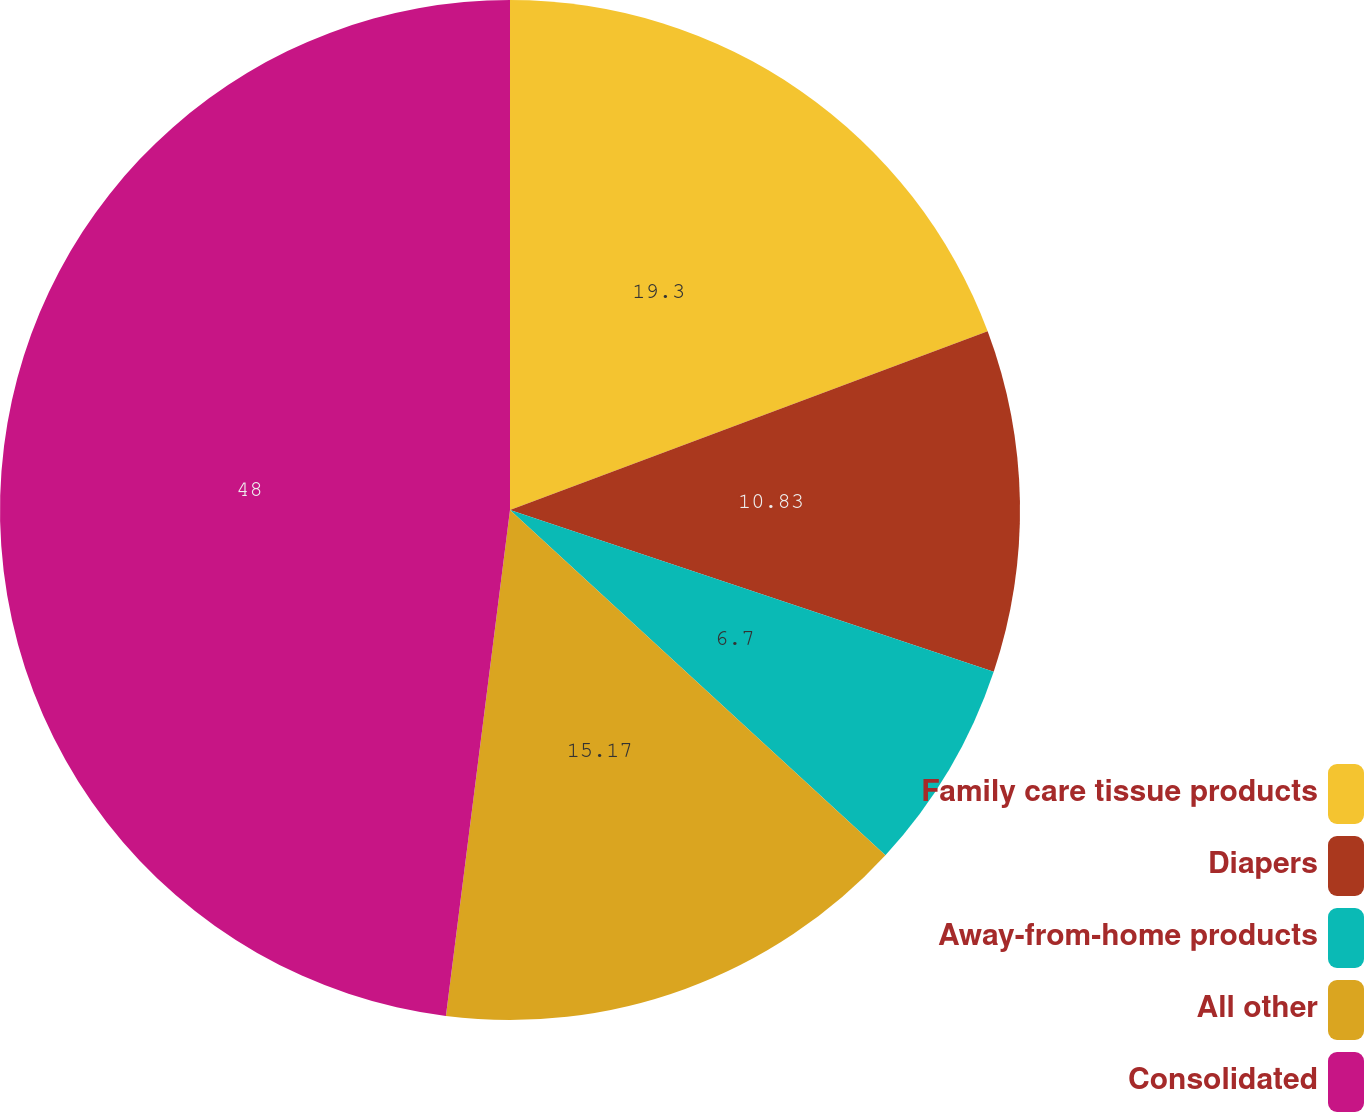<chart> <loc_0><loc_0><loc_500><loc_500><pie_chart><fcel>Family care tissue products<fcel>Diapers<fcel>Away-from-home products<fcel>All other<fcel>Consolidated<nl><fcel>19.3%<fcel>10.83%<fcel>6.7%<fcel>15.17%<fcel>47.99%<nl></chart> 